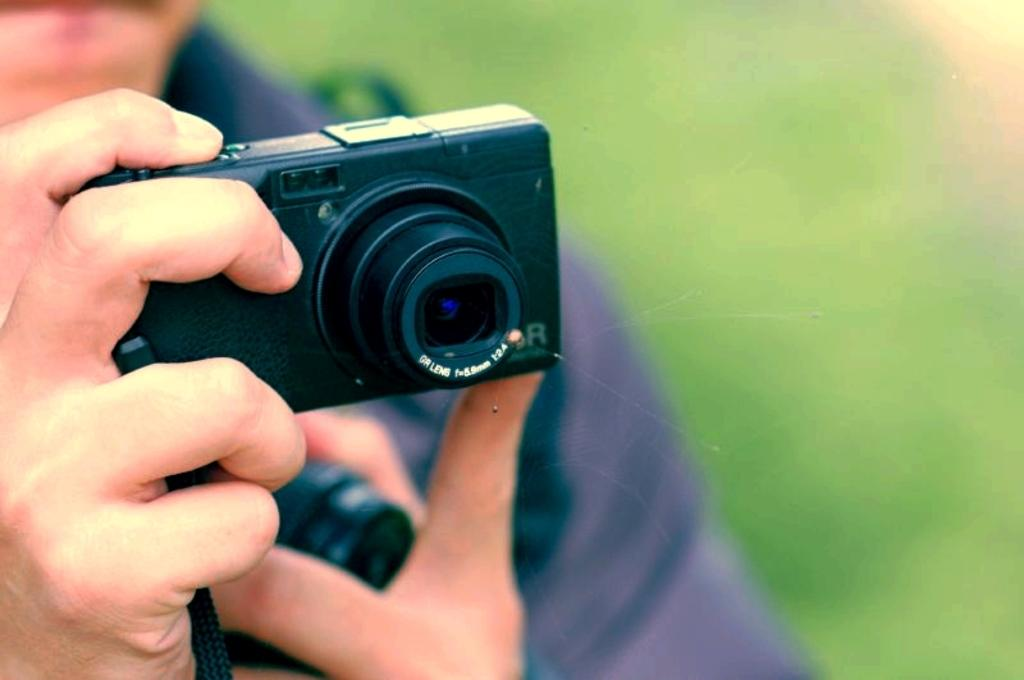Who is the main subject in the image? There is a man in the image. What is the man holding in the image? The man is holding a camera. Can you describe the background of the image? The background of the image is blurry. What type of caption is written on the man's shirt in the image? There is no caption visible on the man's shirt in the image. Can you tell me how many pieces of cheese are on the man's plate in the image? There is no plate or cheese present in the image. 